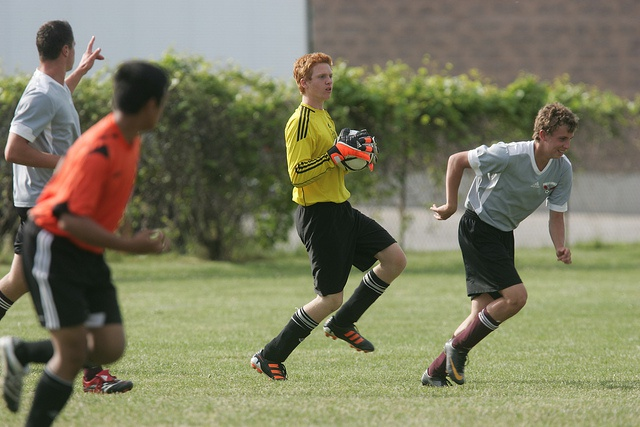Describe the objects in this image and their specific colors. I can see people in darkgray, black, maroon, brown, and gray tones, people in darkgray, black, olive, and gray tones, people in darkgray, gray, black, and maroon tones, people in darkgray, gray, black, and lightgray tones, and sports ball in darkgray, olive, black, and darkgreen tones in this image. 